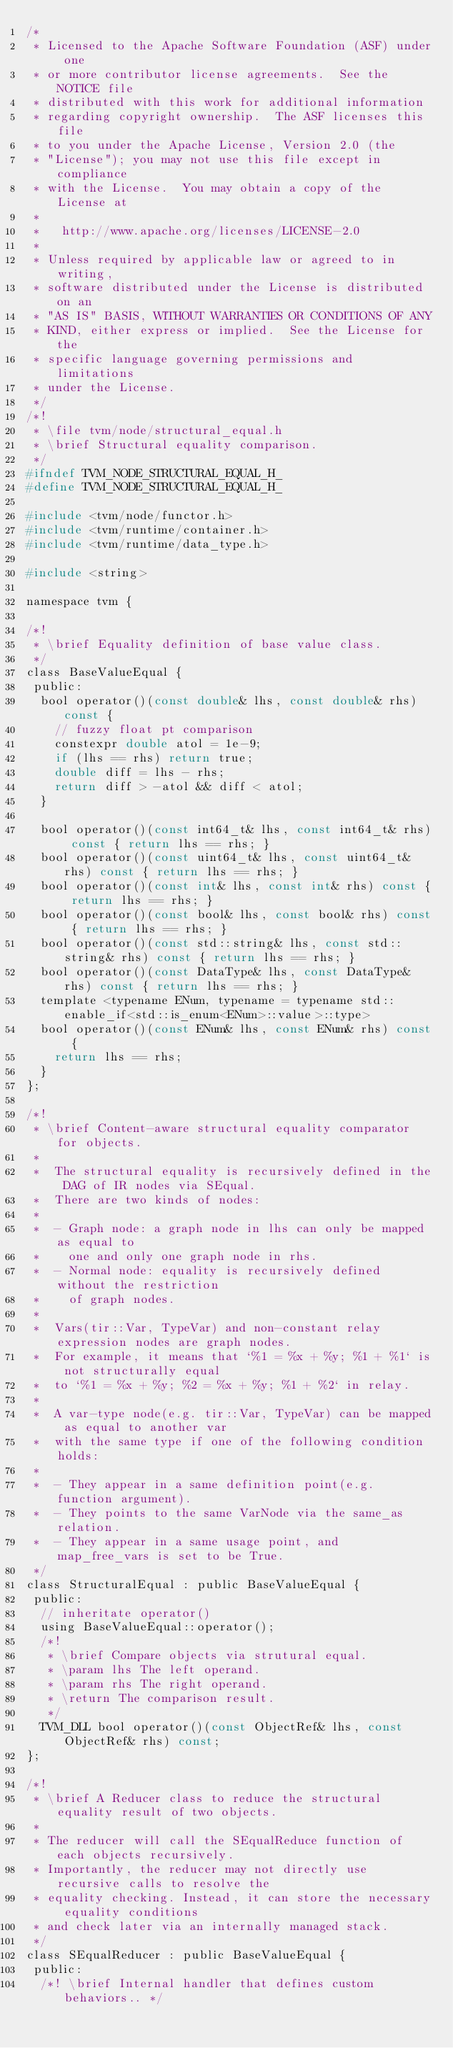<code> <loc_0><loc_0><loc_500><loc_500><_C_>/*
 * Licensed to the Apache Software Foundation (ASF) under one
 * or more contributor license agreements.  See the NOTICE file
 * distributed with this work for additional information
 * regarding copyright ownership.  The ASF licenses this file
 * to you under the Apache License, Version 2.0 (the
 * "License"); you may not use this file except in compliance
 * with the License.  You may obtain a copy of the License at
 *
 *   http://www.apache.org/licenses/LICENSE-2.0
 *
 * Unless required by applicable law or agreed to in writing,
 * software distributed under the License is distributed on an
 * "AS IS" BASIS, WITHOUT WARRANTIES OR CONDITIONS OF ANY
 * KIND, either express or implied.  See the License for the
 * specific language governing permissions and limitations
 * under the License.
 */
/*!
 * \file tvm/node/structural_equal.h
 * \brief Structural equality comparison.
 */
#ifndef TVM_NODE_STRUCTURAL_EQUAL_H_
#define TVM_NODE_STRUCTURAL_EQUAL_H_

#include <tvm/node/functor.h>
#include <tvm/runtime/container.h>
#include <tvm/runtime/data_type.h>

#include <string>

namespace tvm {

/*!
 * \brief Equality definition of base value class.
 */
class BaseValueEqual {
 public:
  bool operator()(const double& lhs, const double& rhs) const {
    // fuzzy float pt comparison
    constexpr double atol = 1e-9;
    if (lhs == rhs) return true;
    double diff = lhs - rhs;
    return diff > -atol && diff < atol;
  }

  bool operator()(const int64_t& lhs, const int64_t& rhs) const { return lhs == rhs; }
  bool operator()(const uint64_t& lhs, const uint64_t& rhs) const { return lhs == rhs; }
  bool operator()(const int& lhs, const int& rhs) const { return lhs == rhs; }
  bool operator()(const bool& lhs, const bool& rhs) const { return lhs == rhs; }
  bool operator()(const std::string& lhs, const std::string& rhs) const { return lhs == rhs; }
  bool operator()(const DataType& lhs, const DataType& rhs) const { return lhs == rhs; }
  template <typename ENum, typename = typename std::enable_if<std::is_enum<ENum>::value>::type>
  bool operator()(const ENum& lhs, const ENum& rhs) const {
    return lhs == rhs;
  }
};

/*!
 * \brief Content-aware structural equality comparator for objects.
 *
 *  The structural equality is recursively defined in the DAG of IR nodes via SEqual.
 *  There are two kinds of nodes:
 *
 *  - Graph node: a graph node in lhs can only be mapped as equal to
 *    one and only one graph node in rhs.
 *  - Normal node: equality is recursively defined without the restriction
 *    of graph nodes.
 *
 *  Vars(tir::Var, TypeVar) and non-constant relay expression nodes are graph nodes.
 *  For example, it means that `%1 = %x + %y; %1 + %1` is not structurally equal
 *  to `%1 = %x + %y; %2 = %x + %y; %1 + %2` in relay.
 *
 *  A var-type node(e.g. tir::Var, TypeVar) can be mapped as equal to another var
 *  with the same type if one of the following condition holds:
 *
 *  - They appear in a same definition point(e.g. function argument).
 *  - They points to the same VarNode via the same_as relation.
 *  - They appear in a same usage point, and map_free_vars is set to be True.
 */
class StructuralEqual : public BaseValueEqual {
 public:
  // inheritate operator()
  using BaseValueEqual::operator();
  /*!
   * \brief Compare objects via strutural equal.
   * \param lhs The left operand.
   * \param rhs The right operand.
   * \return The comparison result.
   */
  TVM_DLL bool operator()(const ObjectRef& lhs, const ObjectRef& rhs) const;
};

/*!
 * \brief A Reducer class to reduce the structural equality result of two objects.
 *
 * The reducer will call the SEqualReduce function of each objects recursively.
 * Importantly, the reducer may not directly use recursive calls to resolve the
 * equality checking. Instead, it can store the necessary equality conditions
 * and check later via an internally managed stack.
 */
class SEqualReducer : public BaseValueEqual {
 public:
  /*! \brief Internal handler that defines custom behaviors.. */</code> 